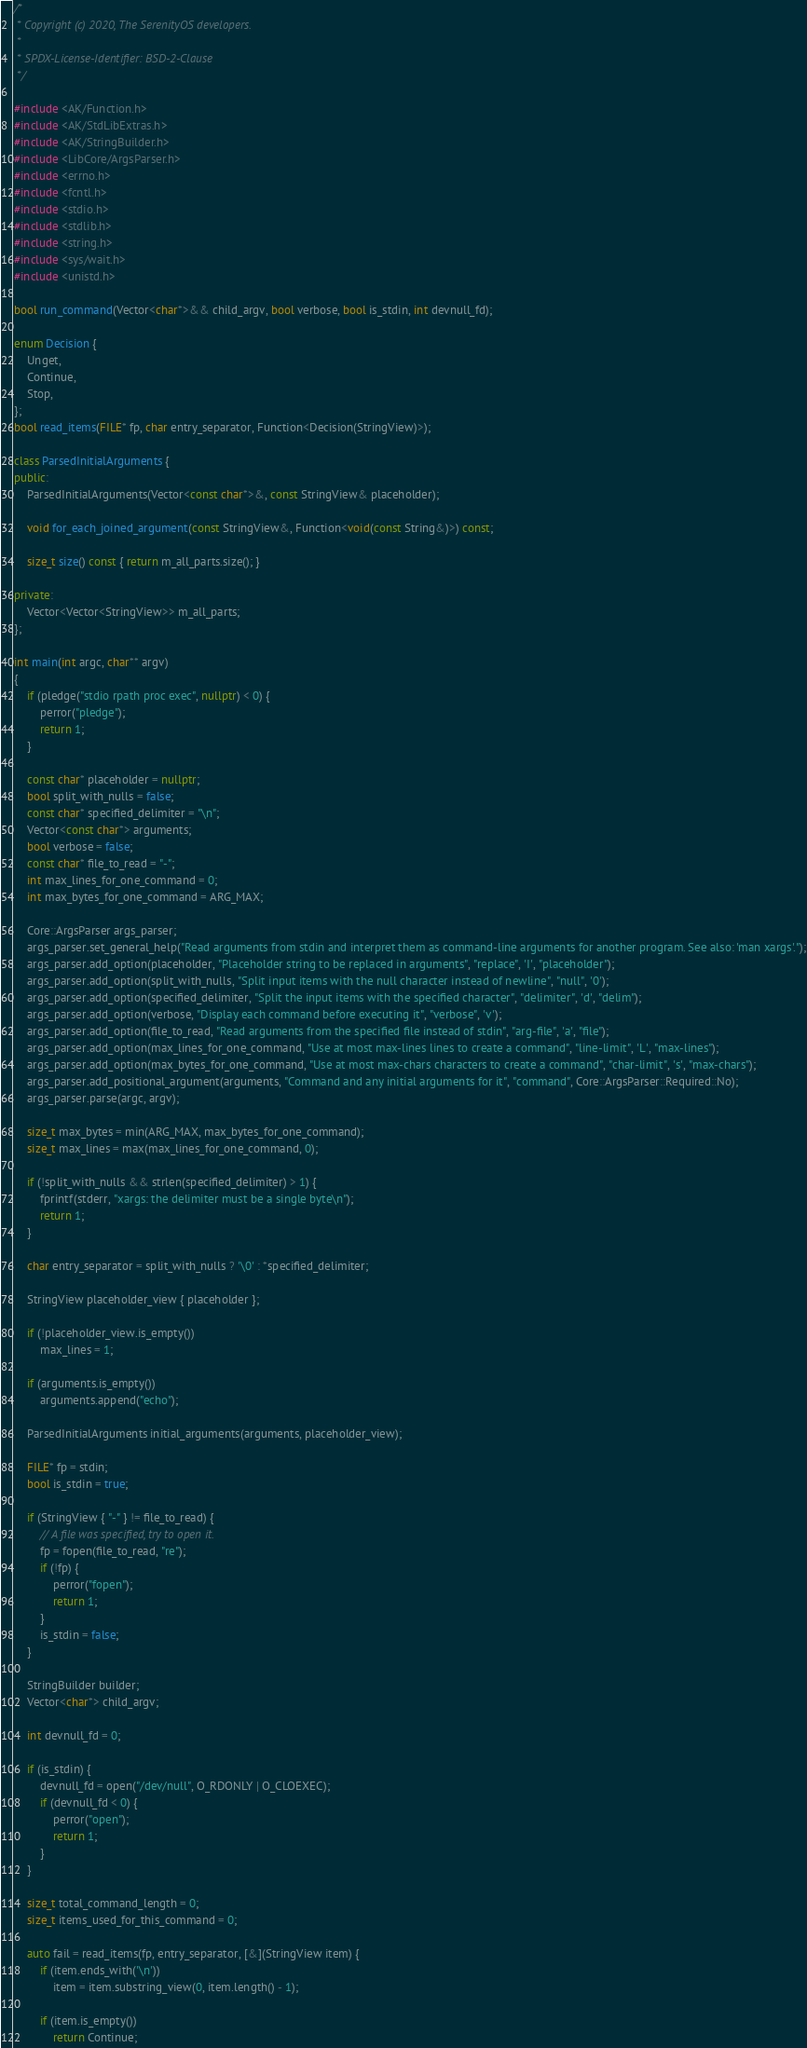Convert code to text. <code><loc_0><loc_0><loc_500><loc_500><_C++_>/*
 * Copyright (c) 2020, The SerenityOS developers.
 *
 * SPDX-License-Identifier: BSD-2-Clause
 */

#include <AK/Function.h>
#include <AK/StdLibExtras.h>
#include <AK/StringBuilder.h>
#include <LibCore/ArgsParser.h>
#include <errno.h>
#include <fcntl.h>
#include <stdio.h>
#include <stdlib.h>
#include <string.h>
#include <sys/wait.h>
#include <unistd.h>

bool run_command(Vector<char*>&& child_argv, bool verbose, bool is_stdin, int devnull_fd);

enum Decision {
    Unget,
    Continue,
    Stop,
};
bool read_items(FILE* fp, char entry_separator, Function<Decision(StringView)>);

class ParsedInitialArguments {
public:
    ParsedInitialArguments(Vector<const char*>&, const StringView& placeholder);

    void for_each_joined_argument(const StringView&, Function<void(const String&)>) const;

    size_t size() const { return m_all_parts.size(); }

private:
    Vector<Vector<StringView>> m_all_parts;
};

int main(int argc, char** argv)
{
    if (pledge("stdio rpath proc exec", nullptr) < 0) {
        perror("pledge");
        return 1;
    }

    const char* placeholder = nullptr;
    bool split_with_nulls = false;
    const char* specified_delimiter = "\n";
    Vector<const char*> arguments;
    bool verbose = false;
    const char* file_to_read = "-";
    int max_lines_for_one_command = 0;
    int max_bytes_for_one_command = ARG_MAX;

    Core::ArgsParser args_parser;
    args_parser.set_general_help("Read arguments from stdin and interpret them as command-line arguments for another program. See also: 'man xargs'.");
    args_parser.add_option(placeholder, "Placeholder string to be replaced in arguments", "replace", 'I', "placeholder");
    args_parser.add_option(split_with_nulls, "Split input items with the null character instead of newline", "null", '0');
    args_parser.add_option(specified_delimiter, "Split the input items with the specified character", "delimiter", 'd', "delim");
    args_parser.add_option(verbose, "Display each command before executing it", "verbose", 'v');
    args_parser.add_option(file_to_read, "Read arguments from the specified file instead of stdin", "arg-file", 'a', "file");
    args_parser.add_option(max_lines_for_one_command, "Use at most max-lines lines to create a command", "line-limit", 'L', "max-lines");
    args_parser.add_option(max_bytes_for_one_command, "Use at most max-chars characters to create a command", "char-limit", 's', "max-chars");
    args_parser.add_positional_argument(arguments, "Command and any initial arguments for it", "command", Core::ArgsParser::Required::No);
    args_parser.parse(argc, argv);

    size_t max_bytes = min(ARG_MAX, max_bytes_for_one_command);
    size_t max_lines = max(max_lines_for_one_command, 0);

    if (!split_with_nulls && strlen(specified_delimiter) > 1) {
        fprintf(stderr, "xargs: the delimiter must be a single byte\n");
        return 1;
    }

    char entry_separator = split_with_nulls ? '\0' : *specified_delimiter;

    StringView placeholder_view { placeholder };

    if (!placeholder_view.is_empty())
        max_lines = 1;

    if (arguments.is_empty())
        arguments.append("echo");

    ParsedInitialArguments initial_arguments(arguments, placeholder_view);

    FILE* fp = stdin;
    bool is_stdin = true;

    if (StringView { "-" } != file_to_read) {
        // A file was specified, try to open it.
        fp = fopen(file_to_read, "re");
        if (!fp) {
            perror("fopen");
            return 1;
        }
        is_stdin = false;
    }

    StringBuilder builder;
    Vector<char*> child_argv;

    int devnull_fd = 0;

    if (is_stdin) {
        devnull_fd = open("/dev/null", O_RDONLY | O_CLOEXEC);
        if (devnull_fd < 0) {
            perror("open");
            return 1;
        }
    }

    size_t total_command_length = 0;
    size_t items_used_for_this_command = 0;

    auto fail = read_items(fp, entry_separator, [&](StringView item) {
        if (item.ends_with('\n'))
            item = item.substring_view(0, item.length() - 1);

        if (item.is_empty())
            return Continue;
</code> 